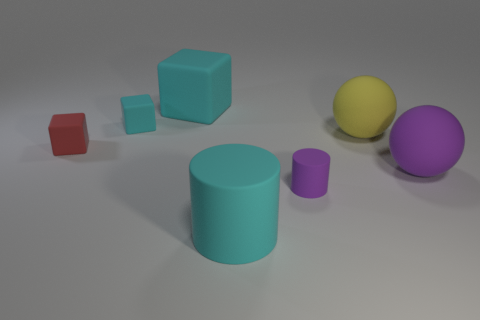What number of things are either cyan rubber things behind the large matte cylinder or rubber objects on the left side of the big rubber cube?
Make the answer very short. 3. There is a big cyan rubber object that is to the right of the cyan matte cube that is to the right of the small cyan rubber cube; what number of matte objects are to the right of it?
Make the answer very short. 3. There is a ball right of the large yellow rubber thing; how big is it?
Offer a very short reply. Large. How many purple balls are the same size as the red rubber thing?
Make the answer very short. 0. There is a yellow rubber ball; does it have the same size as the object left of the tiny cyan thing?
Your answer should be compact. No. How many things are yellow objects or cyan cylinders?
Your answer should be very brief. 2. How many large matte objects have the same color as the big rubber cube?
Provide a succinct answer. 1. There is a purple thing that is the same size as the red matte block; what shape is it?
Give a very brief answer. Cylinder. Are there any cyan objects of the same shape as the big yellow thing?
Offer a terse response. No. What number of blue balls have the same material as the cyan cylinder?
Make the answer very short. 0. 